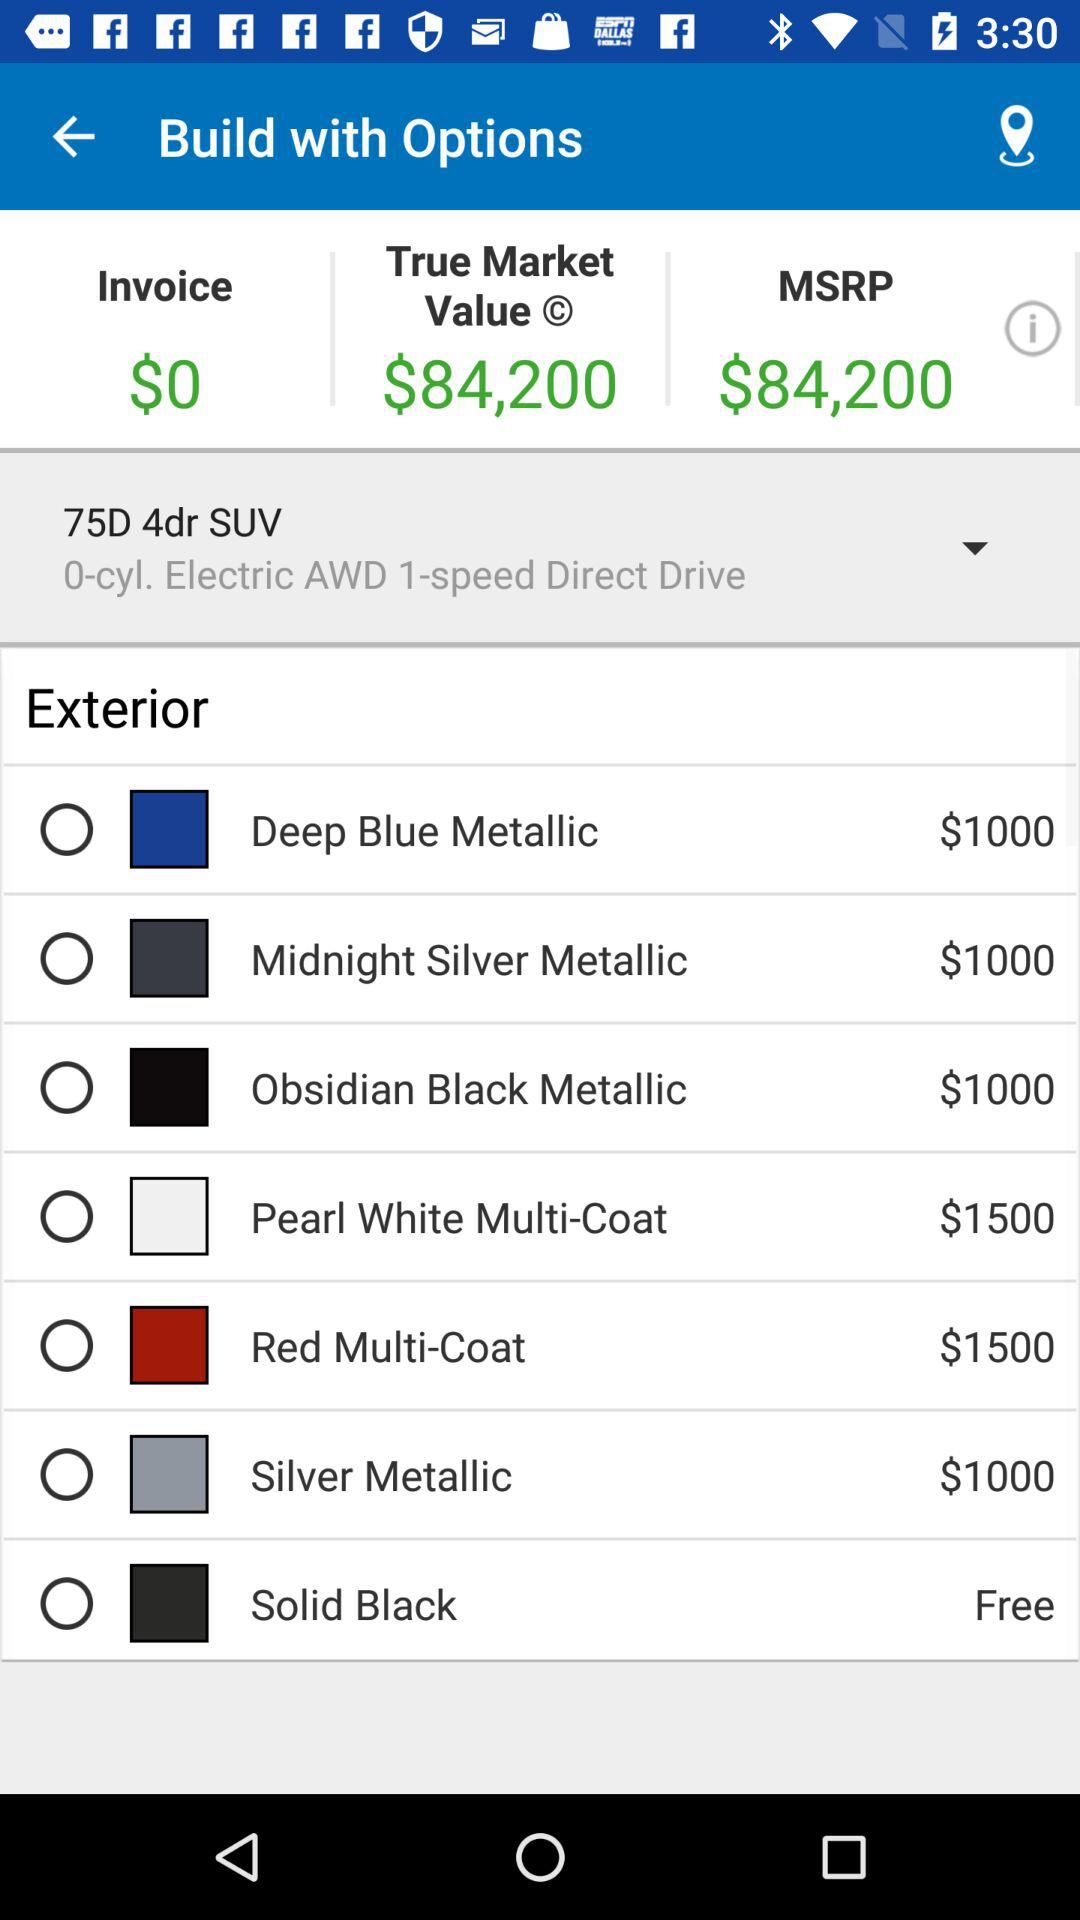What is the true market value? The true market value is 84,200 dollars. 